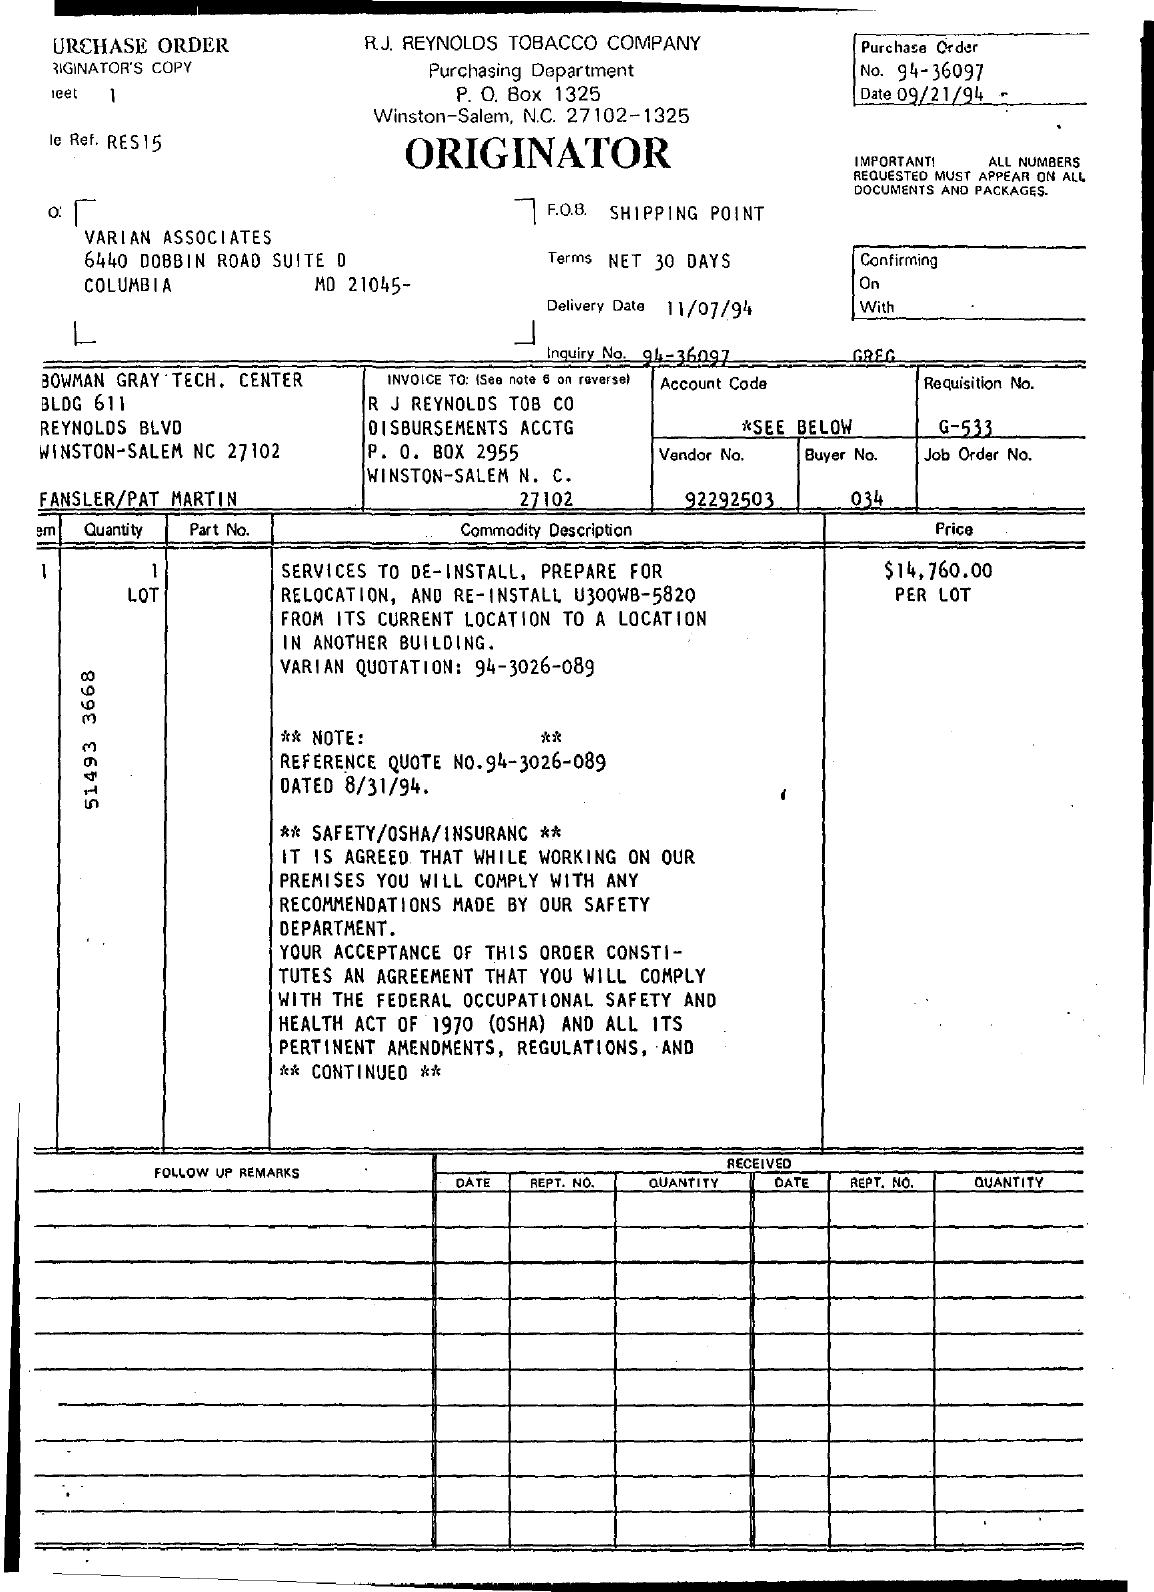Draw attention to some important aspects in this diagram. The purchase order number is 94-36097. The date mentioned at the top of the document is 09/21/94. The F.O.B. Field, which stands for "Free on Board," indicates the location where the shipment will be prepared for transportation. Specifically, the Shipping Point is indicated in the F.O.B. Field. This information is important for determining the seller's responsibility and the cost of shipping the goods. The P.O Box Number of the document is 1325. The buyer number is 034. 